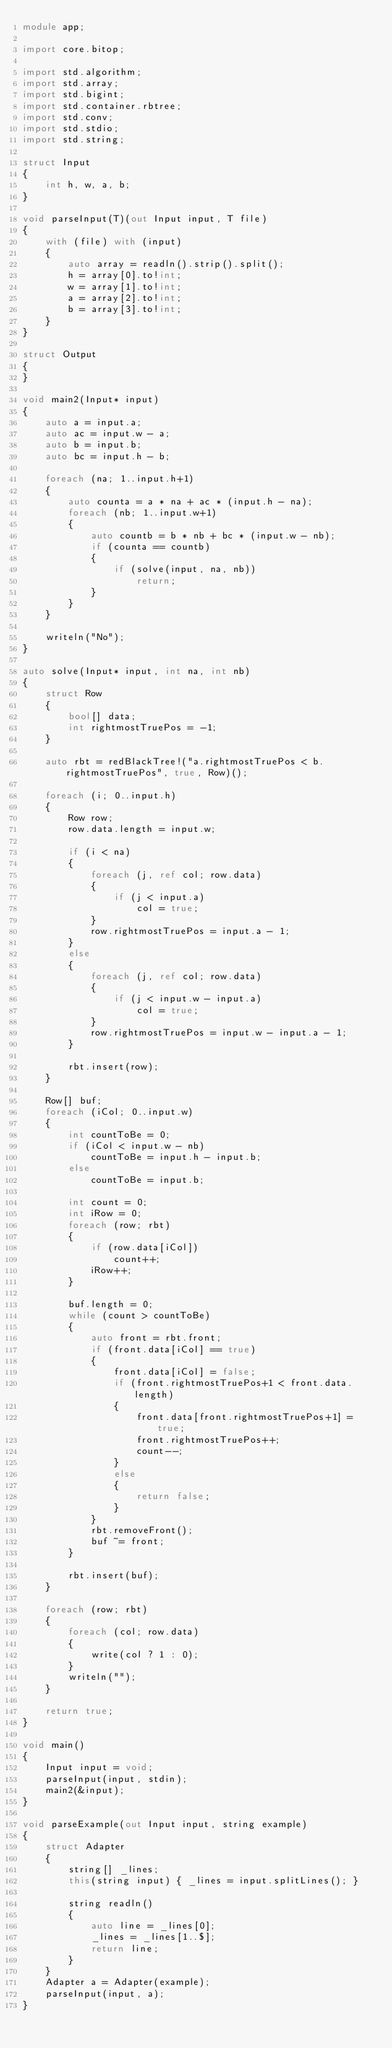Convert code to text. <code><loc_0><loc_0><loc_500><loc_500><_D_>module app;

import core.bitop;

import std.algorithm;
import std.array;
import std.bigint;
import std.container.rbtree;
import std.conv;
import std.stdio;
import std.string;

struct Input
{
    int h, w, a, b;
}

void parseInput(T)(out Input input, T file)
{
    with (file) with (input)
    {
        auto array = readln().strip().split();
        h = array[0].to!int;
        w = array[1].to!int;
        a = array[2].to!int;
        b = array[3].to!int;
    }
}

struct Output
{
}

void main2(Input* input)
{
    auto a = input.a;
    auto ac = input.w - a;
    auto b = input.b;
    auto bc = input.h - b;

    foreach (na; 1..input.h+1)
    {
        auto counta = a * na + ac * (input.h - na);
        foreach (nb; 1..input.w+1)
        {
            auto countb = b * nb + bc * (input.w - nb);
            if (counta == countb)
            {
                if (solve(input, na, nb))
                    return;
            }
        }
    }

    writeln("No");
}

auto solve(Input* input, int na, int nb)
{
    struct Row
    {
        bool[] data;
        int rightmostTruePos = -1;
    }

    auto rbt = redBlackTree!("a.rightmostTruePos < b.rightmostTruePos", true, Row)();

    foreach (i; 0..input.h)
    {
        Row row;
        row.data.length = input.w;

        if (i < na)
        {
            foreach (j, ref col; row.data)
            {
                if (j < input.a)
                    col = true;
            }
            row.rightmostTruePos = input.a - 1;
        }
        else
        {
            foreach (j, ref col; row.data)
            {
                if (j < input.w - input.a)
                    col = true;
            }
            row.rightmostTruePos = input.w - input.a - 1;
        }

        rbt.insert(row);
    }

    Row[] buf;
    foreach (iCol; 0..input.w)
    {
        int countToBe = 0;
        if (iCol < input.w - nb)
            countToBe = input.h - input.b;
        else
            countToBe = input.b;

        int count = 0;
        int iRow = 0;
        foreach (row; rbt)
        {
            if (row.data[iCol])
                count++;
            iRow++;
        }

        buf.length = 0;
        while (count > countToBe)
        {
            auto front = rbt.front;
            if (front.data[iCol] == true)
            {
                front.data[iCol] = false;
                if (front.rightmostTruePos+1 < front.data.length)
                {
                    front.data[front.rightmostTruePos+1] = true;
                    front.rightmostTruePos++;
                    count--;
                }
                else
                {
                    return false;
                }
            }
            rbt.removeFront();
            buf ~= front;
        }

        rbt.insert(buf);
    }

    foreach (row; rbt)
    {
        foreach (col; row.data)
        {
            write(col ? 1 : 0);
        }
        writeln("");
    }

    return true;
}

void main()
{
    Input input = void;
    parseInput(input, stdin);
    main2(&input);
}

void parseExample(out Input input, string example)
{
    struct Adapter
    {
        string[] _lines;
        this(string input) { _lines = input.splitLines(); }

        string readln()
        {
            auto line = _lines[0];
            _lines = _lines[1..$];
            return line;
        }
    }
    Adapter a = Adapter(example);
    parseInput(input, a);
}
</code> 